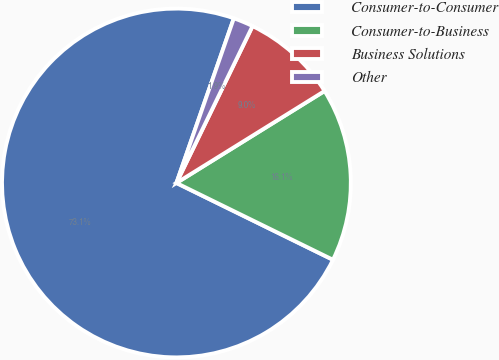Convert chart to OTSL. <chart><loc_0><loc_0><loc_500><loc_500><pie_chart><fcel>Consumer-to-Consumer<fcel>Consumer-to-Business<fcel>Business Solutions<fcel>Other<nl><fcel>73.08%<fcel>16.1%<fcel>8.97%<fcel>1.85%<nl></chart> 